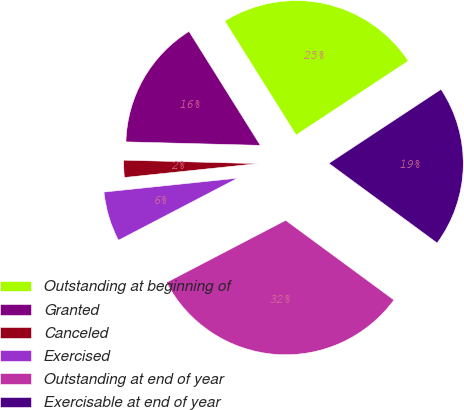Convert chart. <chart><loc_0><loc_0><loc_500><loc_500><pie_chart><fcel>Outstanding at beginning of<fcel>Granted<fcel>Canceled<fcel>Exercised<fcel>Outstanding at end of year<fcel>Exercisable at end of year<nl><fcel>24.62%<fcel>15.69%<fcel>2.06%<fcel>6.0%<fcel>32.26%<fcel>19.38%<nl></chart> 